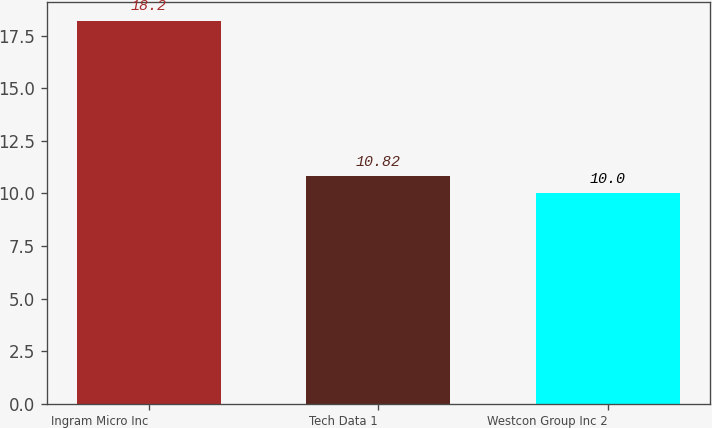Convert chart. <chart><loc_0><loc_0><loc_500><loc_500><bar_chart><fcel>Ingram Micro Inc<fcel>Tech Data 1<fcel>Westcon Group Inc 2<nl><fcel>18.2<fcel>10.82<fcel>10<nl></chart> 